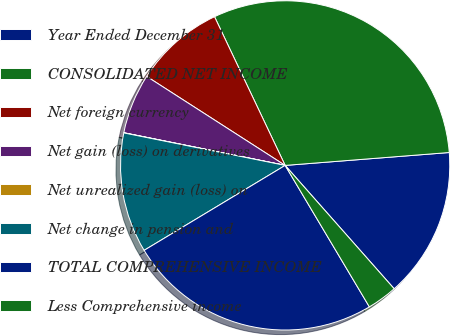<chart> <loc_0><loc_0><loc_500><loc_500><pie_chart><fcel>Year Ended December 31<fcel>CONSOLIDATED NET INCOME<fcel>Net foreign currency<fcel>Net gain (loss) on derivatives<fcel>Net unrealized gain (loss) on<fcel>Net change in pension and<fcel>TOTAL COMPREHENSIVE INCOME<fcel>Less Comprehensive income<nl><fcel>14.73%<fcel>30.81%<fcel>8.85%<fcel>5.91%<fcel>0.02%<fcel>11.79%<fcel>24.92%<fcel>2.97%<nl></chart> 